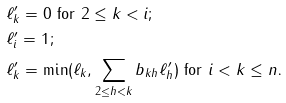<formula> <loc_0><loc_0><loc_500><loc_500>& \text {$\ell^{\prime}_{k} = 0$ for $2 \leq k <i$;} \\ & \text {$\ell^{\prime}_{i} = 1$;} \\ & \text {$\ell^{\prime}_{k} = \min(\ell_{k}, \sum_{2\leq h < k} b_{kh} \ell^{\prime}_{h})$ for $i < k \leq n$.}</formula> 